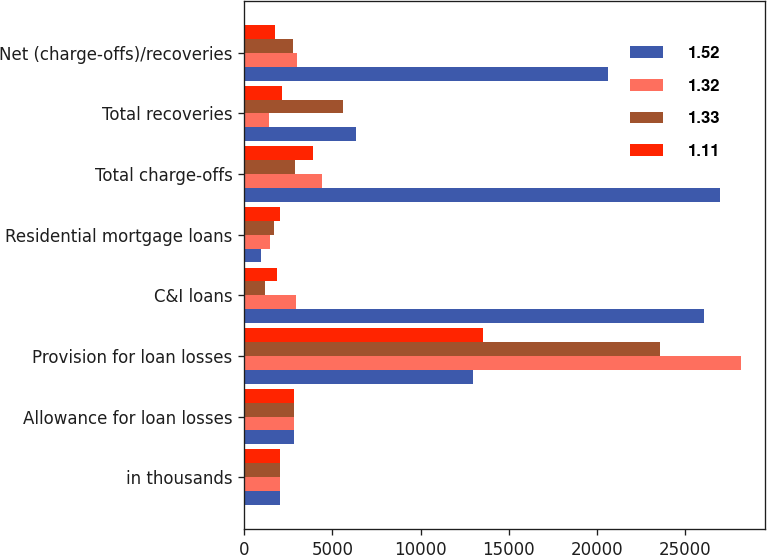Convert chart. <chart><loc_0><loc_0><loc_500><loc_500><stacked_bar_chart><ecel><fcel>in thousands<fcel>Allowance for loan losses<fcel>Provision for loan losses<fcel>C&I loans<fcel>Residential mortgage loans<fcel>Total charge-offs<fcel>Total recoveries<fcel>Net (charge-offs)/recoveries<nl><fcel>1.52<fcel>2017<fcel>2807.5<fcel>12987<fcel>26088<fcel>918<fcel>27006<fcel>6354<fcel>20652<nl><fcel>1.32<fcel>2016<fcel>2807.5<fcel>28167<fcel>2956<fcel>1470<fcel>4426<fcel>1417<fcel>3009<nl><fcel>1.33<fcel>2015<fcel>2807.5<fcel>23570<fcel>1191<fcel>1667<fcel>2858<fcel>5615<fcel>2757<nl><fcel>1.11<fcel>2014<fcel>2807.5<fcel>13565<fcel>1845<fcel>2015<fcel>3876<fcel>2129<fcel>1747<nl></chart> 